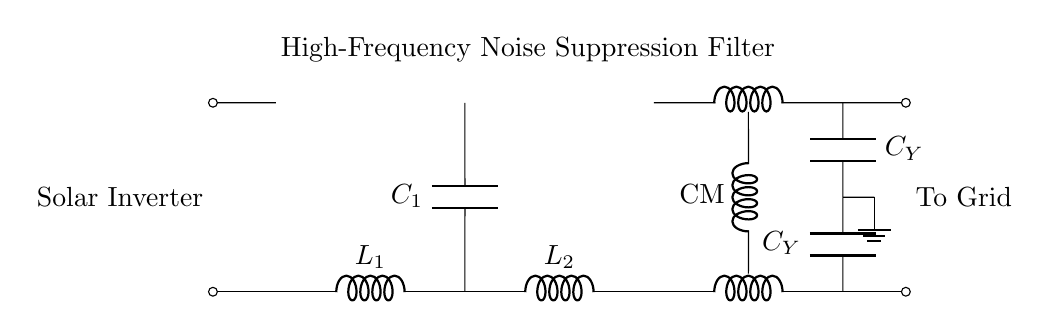What type of filter is displayed in the circuit? The circuit represents a high-frequency noise suppression filter, which is indicated by the label above the components in the diagram.
Answer: high-frequency noise suppression filter How many inductors are present in the circuit? There are three inductors in total: two labeled L1 and L2, and a common mode choke represented by CM1 and CM2 together.
Answer: three What is the role of capacitors in this circuit? The capacitors, labeled C1 and C_Y, are used to filter out high-frequency noise, providing a path to ground for high-frequency signals which helps to improve the quality of the output signal.
Answer: filter high-frequency noise Which components are parallel to each other? The two capacitors C_Y are in parallel, as they connect to the same node while each connects to a different voltage level, sharing a common connection point.
Answer: C_Y capacitors What is the output of the circuit connected to? The output is connected to the grid, as indicated by the label on the right side of the diagram, showing the termination point of the circuit.
Answer: grid What is the function of the common mode choke? The common mode choke (CM) is used to suppress common mode noise, which means it helps to filter out noise that travels in the same direction on both conductors, enhancing noise immunity in the circuit.
Answer: suppress common mode noise What is the purpose of ground in this circuit? The ground serves as a reference point for the circuit's voltage levels, providing a return path for electrical current and stabilizing the circuit by preventing floating voltages.
Answer: reference point 